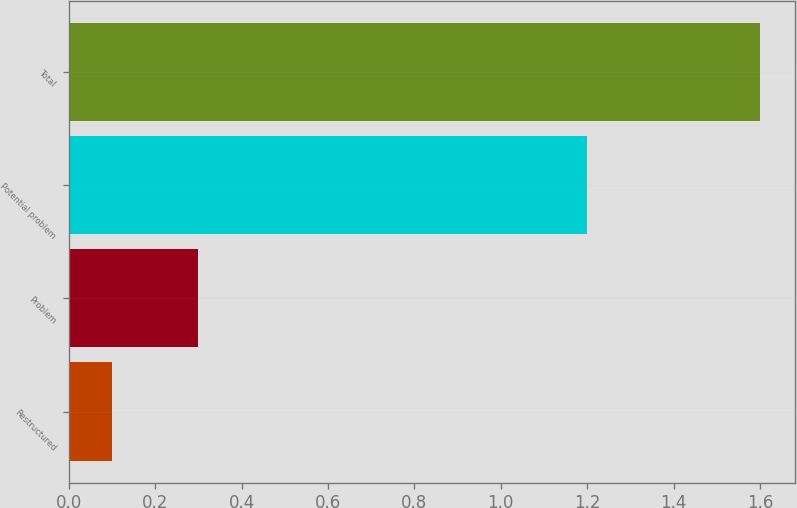<chart> <loc_0><loc_0><loc_500><loc_500><bar_chart><fcel>Restructured<fcel>Problem<fcel>Potential problem<fcel>Total<nl><fcel>0.1<fcel>0.3<fcel>1.2<fcel>1.6<nl></chart> 